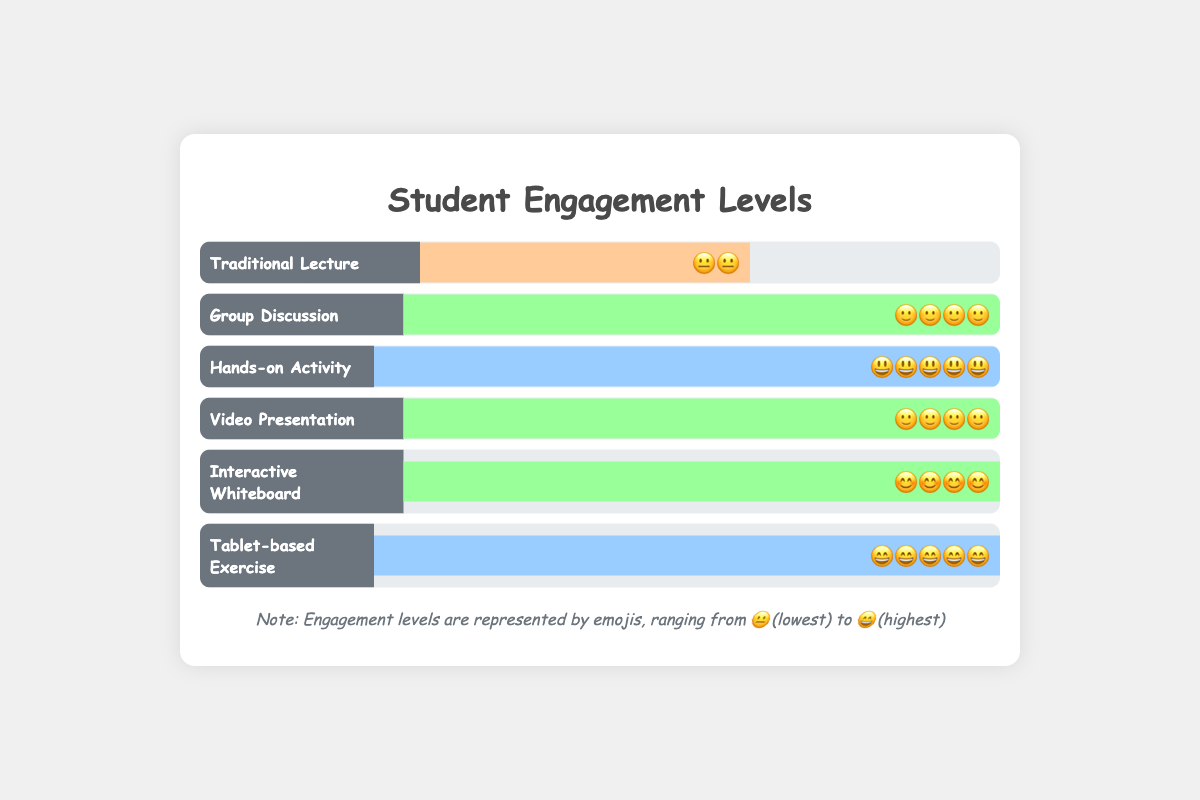Which lesson type has the highest engagement level? The lesson types "Hands-on Activity" and "Tablet-based Exercise" both have the highest engagement level with a score of 5, which is represented by the emojis 😃 and 😄 respectively.
Answer: Hands-on Activity, Tablet-based Exercise Which lesson type has the lowest engagement level? The "Traditional Lecture" has the lowest engagement level with a score of 2 which is represented by the emoji 😐.
Answer: Traditional Lecture How many lesson types have an engagement level of 4? The lesson types "Group Discussion", "Video Presentation", and "Interactive Whiteboard" each have an engagement level of 4. There are 3 lesson types in total.
Answer: 3 What is the sum of engagement scores for "Group Discussion" and "Video Presentation"? The engagement score for "Group Discussion" is 4 and for "Video Presentation" is 4. The sum is 4 + 4 = 8.
Answer: 8 Which engagement level emoji appears most frequently? The emojis for engagement levels of 4: 🙂 (Group Discussion and Video Presentation) and 😊 (Interactive Whiteboard) together appear most frequently, appearing 3 times in total.
Answer: 🙂 Compare the engagement scores for "Interactive Whiteboard" and "Tablet-based Exercise". Which one is higher and by how much? "Interactive Whiteboard" has a score of 4 and "Tablet-based Exercise" has a score of 5. The difference is 1. Therefore, "Tablet-based Exercise" is higher by 1.
Answer: Tablet-based Exercise by 1 Are there any lesson types with an engagement level of 3? By inspecting the chart, no lesson type has an engagement level of 3.
Answer: No What is the average engagement score of all lesson types? To find the average engagement score, sum all the scores: 2 (Traditional Lecture) + 4 (Group Discussion) + 5 (Hands-on Activity) + 4 (Video Presentation) + 4 (Interactive Whiteboard) + 5 (Tablet-based Exercise) = 24. There are 6 lesson types, so the average is 24 / 6 = 4.
Answer: 4 Between "Traditional Lecture" and "Hands-on Activity", which has a more positive emoji and by what score difference? "Traditional Lecture" has the emoji 😐 (score 2) and "Hands-on Activity" has the emoji 😃 (score 5). The difference in score is 5 - 2 = 3.
Answer: Hands-on Activity by 3 